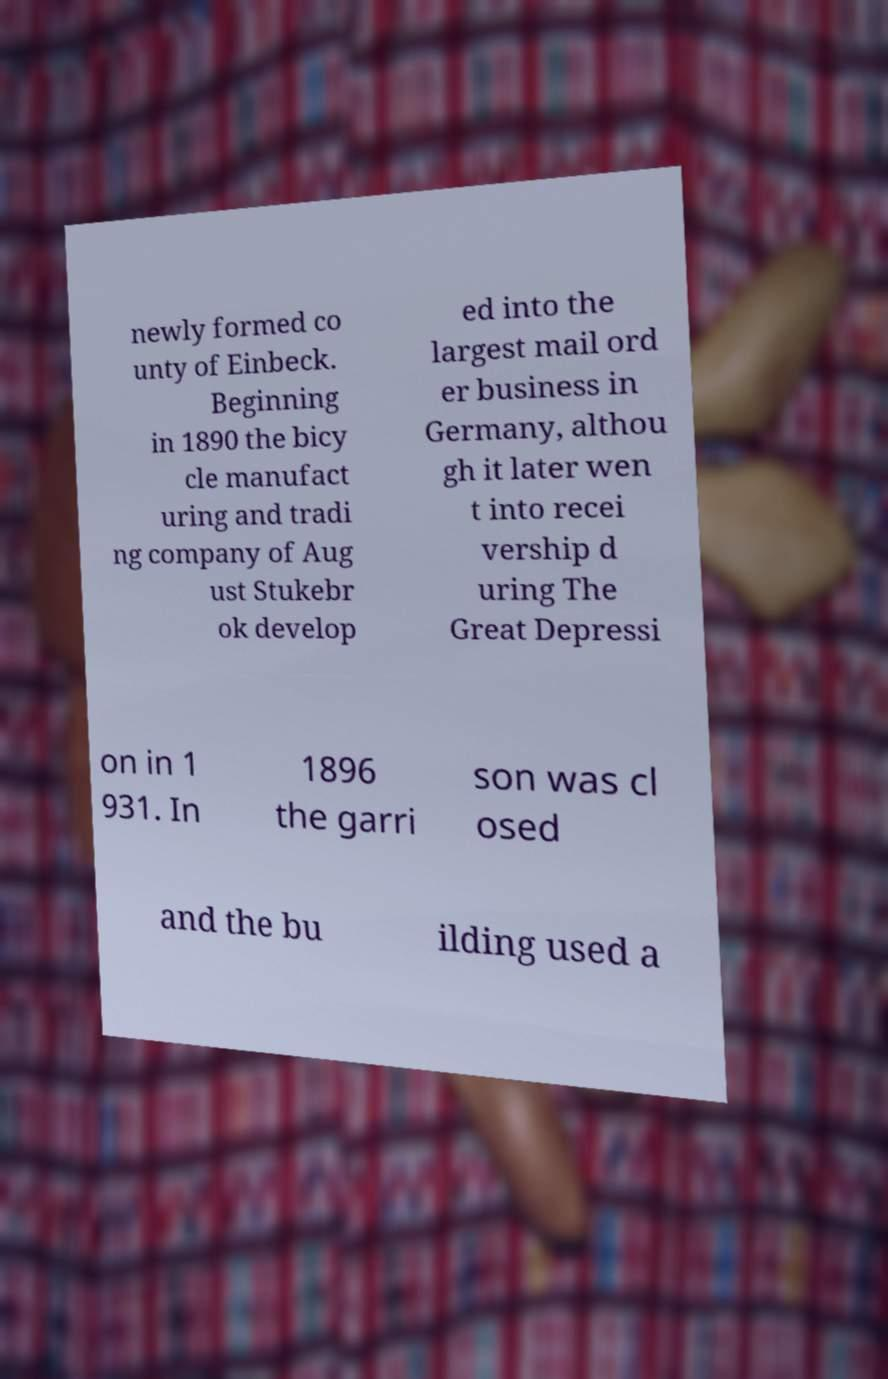What messages or text are displayed in this image? I need them in a readable, typed format. newly formed co unty of Einbeck. Beginning in 1890 the bicy cle manufact uring and tradi ng company of Aug ust Stukebr ok develop ed into the largest mail ord er business in Germany, althou gh it later wen t into recei vership d uring The Great Depressi on in 1 931. In 1896 the garri son was cl osed and the bu ilding used a 